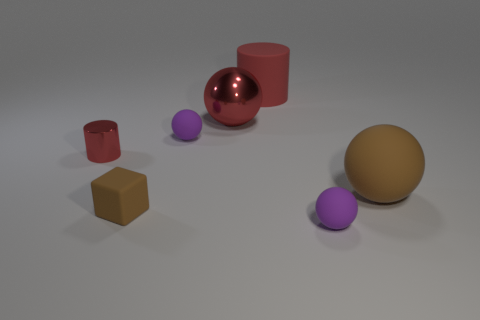Is there a small purple thing right of the big sphere behind the brown matte object that is behind the tiny brown thing?
Make the answer very short. Yes. There is a red ball; are there any tiny purple matte things on the left side of it?
Make the answer very short. Yes. Is there a matte ball that has the same color as the tiny block?
Ensure brevity in your answer.  Yes. What number of small things are either red rubber things or blocks?
Your answer should be very brief. 1. Do the big red sphere to the right of the red metallic cylinder and the small cylinder have the same material?
Your answer should be compact. Yes. The metal thing in front of the large metal thing on the left side of the small purple matte object in front of the large rubber ball is what shape?
Your answer should be compact. Cylinder. What number of gray things are tiny spheres or rubber cylinders?
Your answer should be very brief. 0. Are there an equal number of matte objects behind the red metallic cylinder and tiny purple matte spheres behind the brown block?
Provide a short and direct response. No. Does the small purple thing behind the small brown thing have the same shape as the purple thing in front of the tiny red metal object?
Provide a succinct answer. Yes. Is there anything else that has the same shape as the tiny brown matte thing?
Ensure brevity in your answer.  No. 